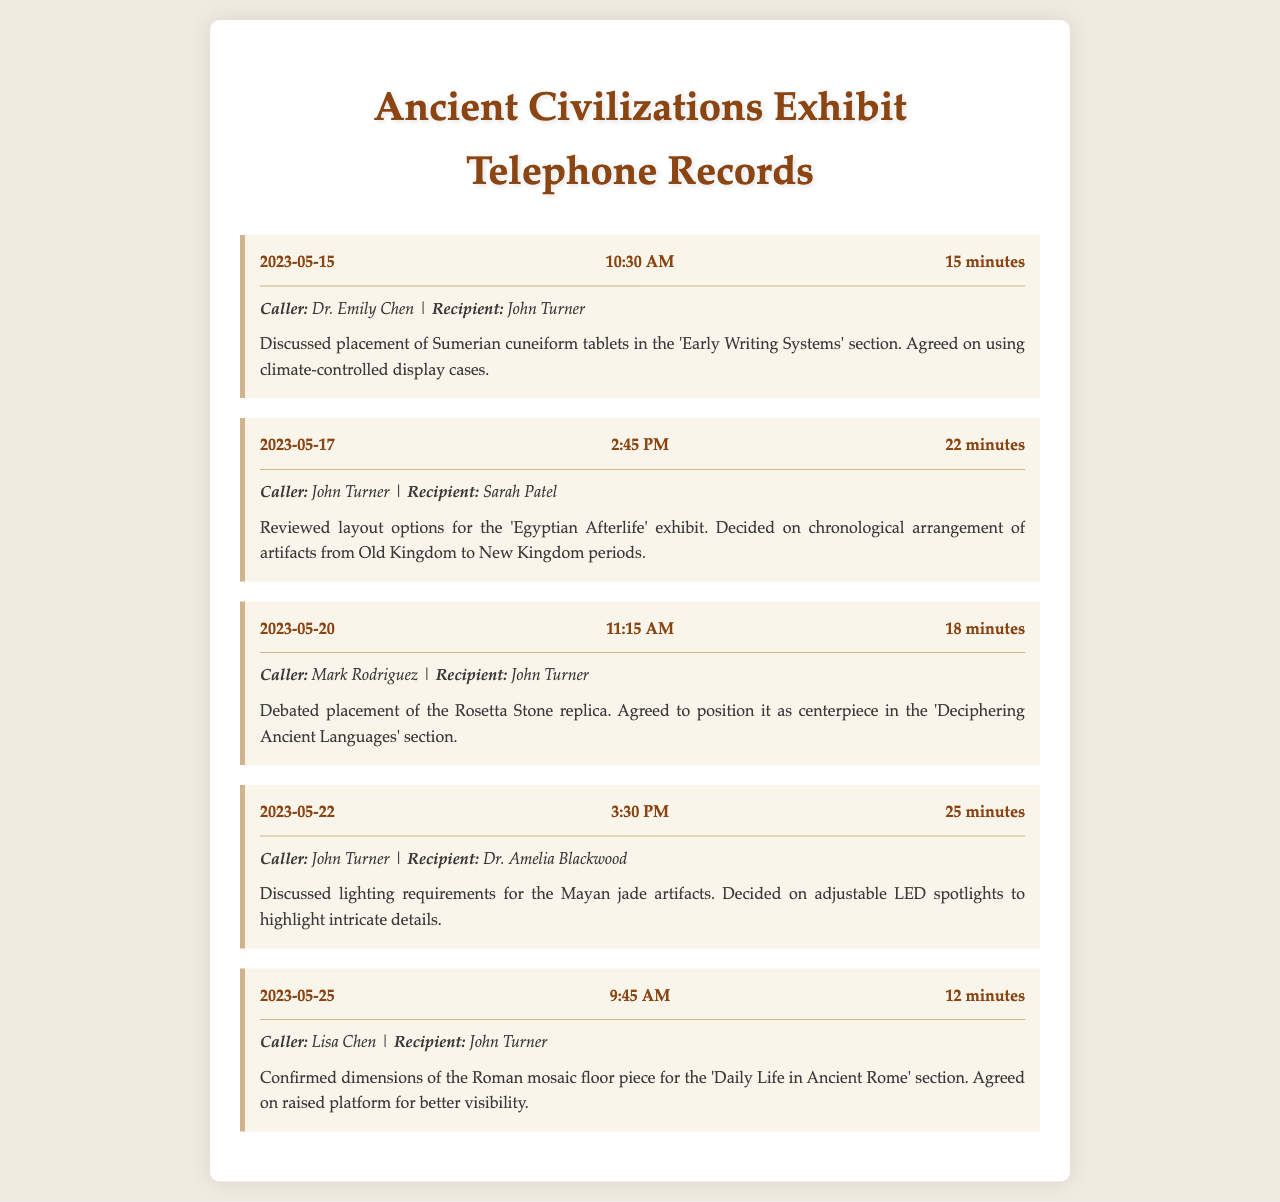What date was the call about the Sumerian cuneiform tablets? The document details several calls, and the discussion on Sumerian cuneiform tablets occurred on May 15, 2023.
Answer: May 15, 2023 Who was involved in the call on May 17, 2023? The call on that date was between John Turner and Sarah Patel.
Answer: John Turner, Sarah Patel What artifact was discussed as a centerpiece on May 20, 2023? The document states that the Rosetta Stone replica was agreed upon as the centerpiece for the 'Deciphering Ancient Languages' section.
Answer: Rosetta Stone replica How long was the call regarding lighting requirements for Mayan jade artifacts? This call took 25 minutes as documented under the call details for May 22, 2023.
Answer: 25 minutes What type of lighting was decided for the Mayan artifacts? The summary mentions that adjustable LED spotlights were chosen to highlight the details of the artifacts.
Answer: adjustable LED spotlights Which section did the delivery of the Roman mosaic floor piece pertain to? The document explicitly indicates that it was for the 'Daily Life in Ancient Rome' section.
Answer: Daily Life in Ancient Rome How many participants were involved in the call on May 25, 2023? The call involved two participants: Lisa Chen and John Turner.
Answer: 2 What was the duration of the call on May 15, 2023? According to the record, the duration of this call was 15 minutes.
Answer: 15 minutes 